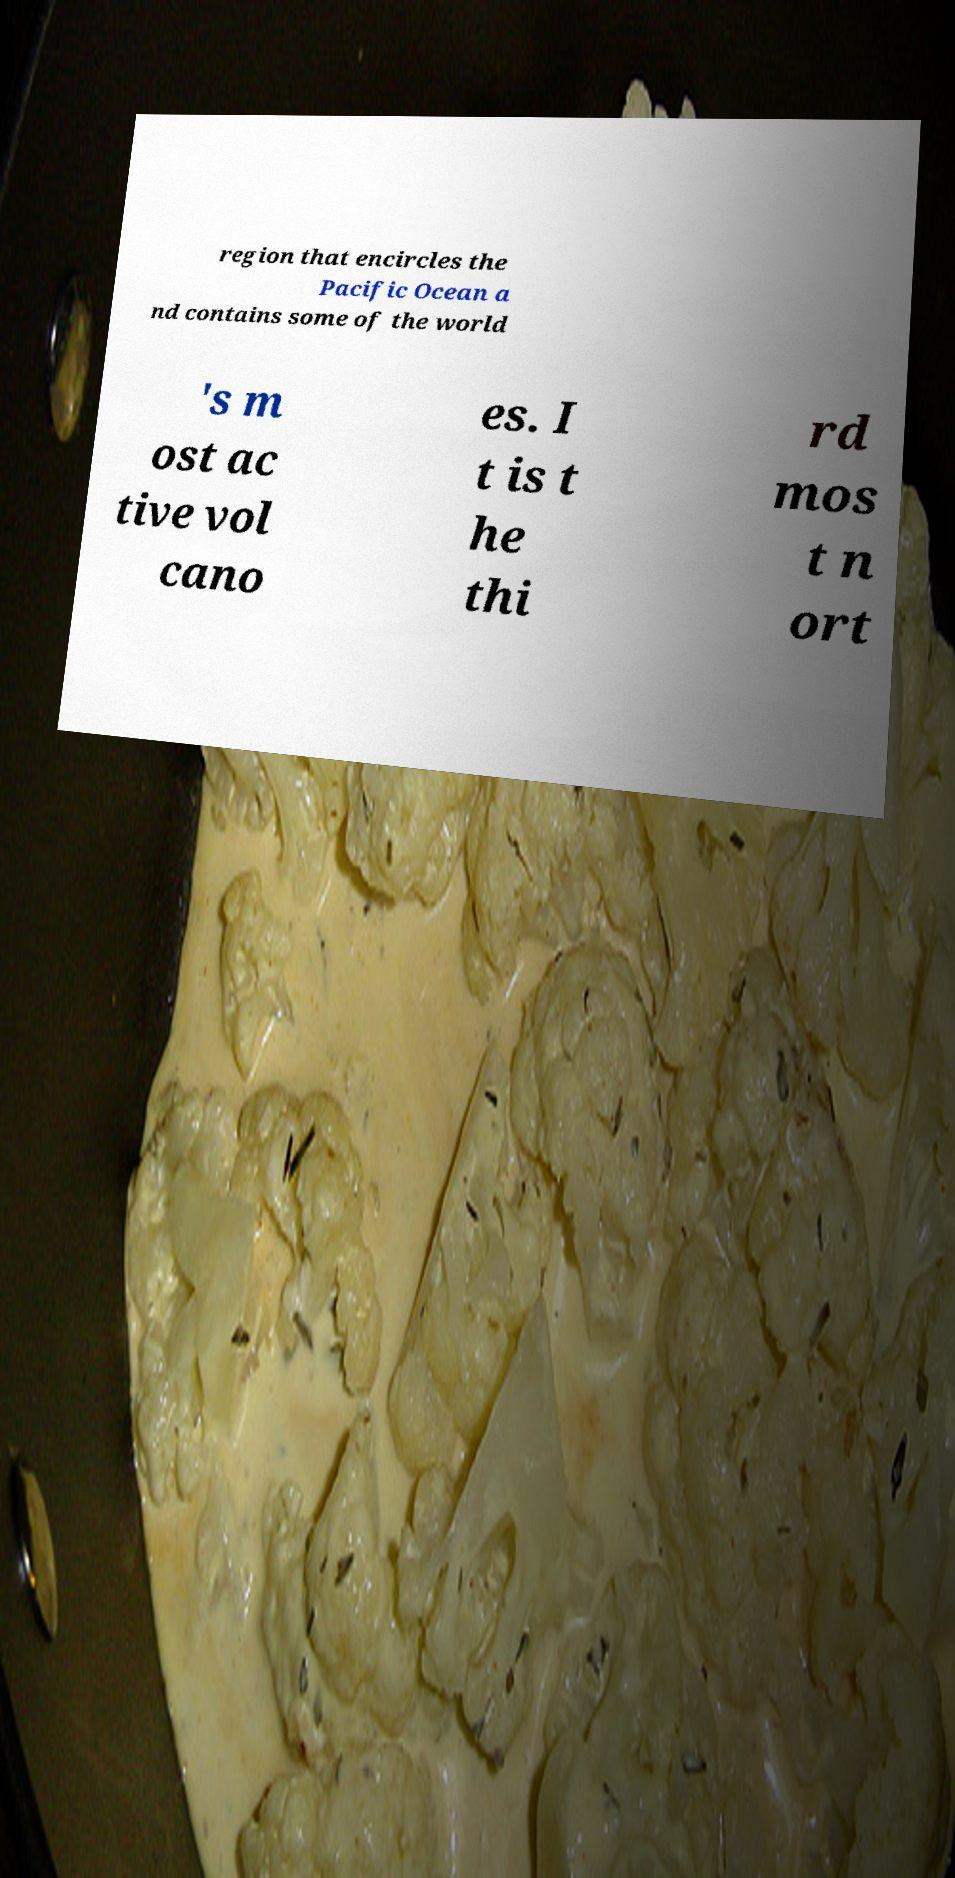Could you extract and type out the text from this image? region that encircles the Pacific Ocean a nd contains some of the world 's m ost ac tive vol cano es. I t is t he thi rd mos t n ort 